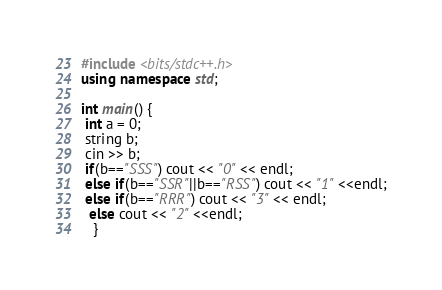<code> <loc_0><loc_0><loc_500><loc_500><_C++_>#include <bits/stdc++.h>
using namespace std;

int main() {
 int a = 0;
 string b;
 cin >> b;
 if(b=="SSS") cout << "0" << endl;
 else if(b=="SSR"||b=="RSS") cout << "1" <<endl;
 else if(b=="RRR") cout << "3" << endl;
  else cout << "2" <<endl;
   }
</code> 